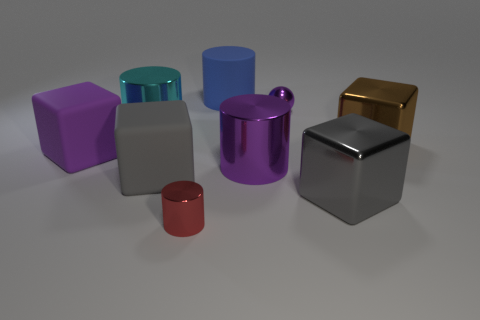Subtract all gray cylinders. Subtract all gray spheres. How many cylinders are left? 4 Add 1 tiny red cylinders. How many objects exist? 10 Subtract all cylinders. How many objects are left? 5 Add 5 red things. How many red things are left? 6 Add 3 cylinders. How many cylinders exist? 7 Subtract 0 cyan spheres. How many objects are left? 9 Subtract all large purple cylinders. Subtract all brown matte balls. How many objects are left? 8 